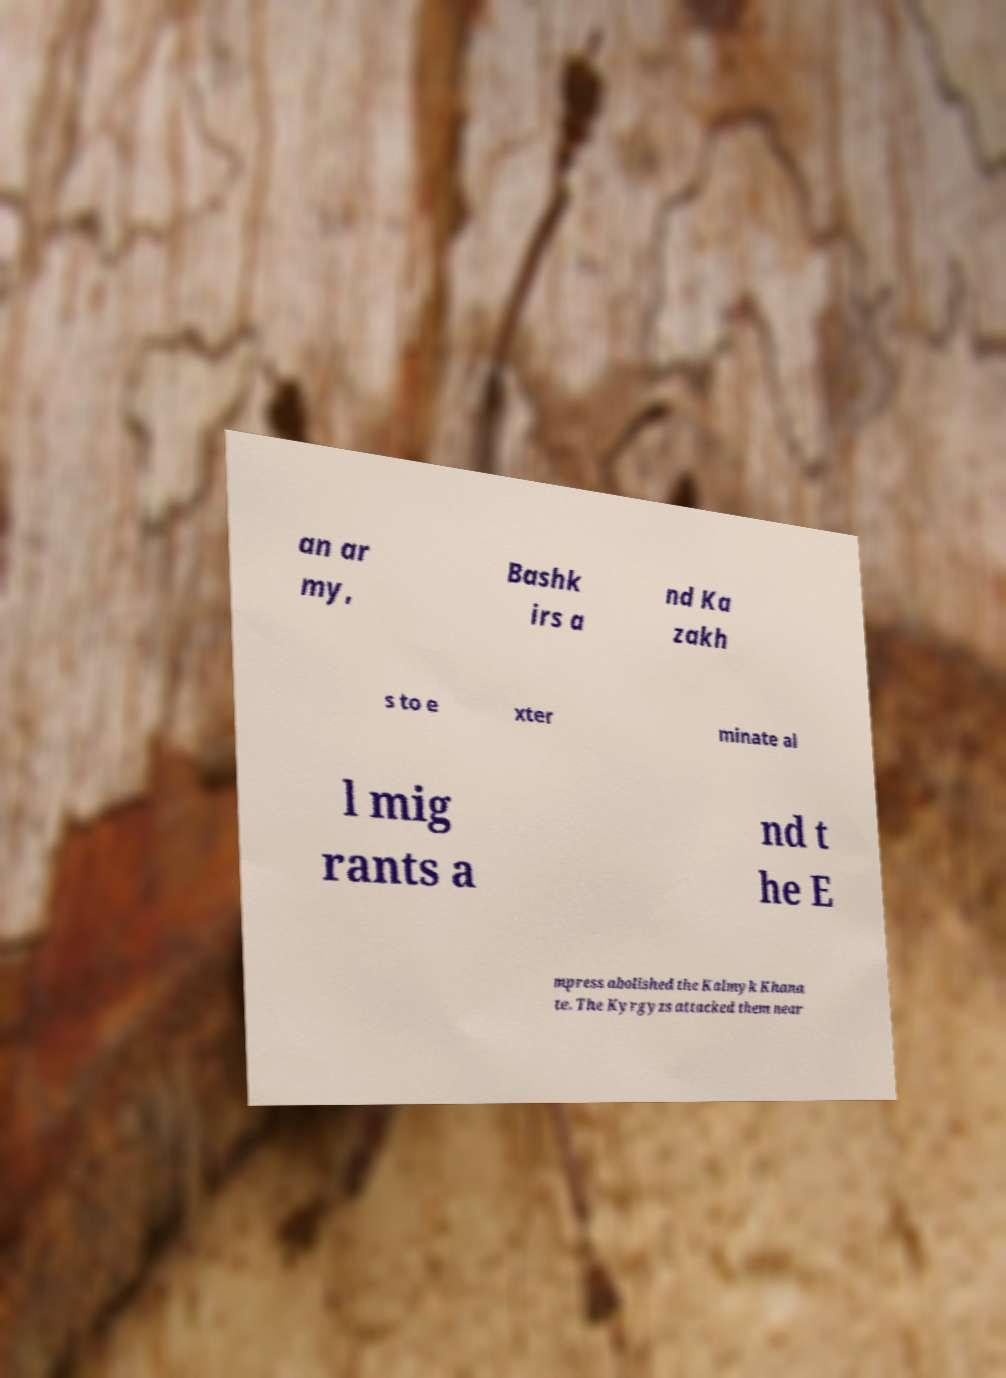There's text embedded in this image that I need extracted. Can you transcribe it verbatim? an ar my, Bashk irs a nd Ka zakh s to e xter minate al l mig rants a nd t he E mpress abolished the Kalmyk Khana te. The Kyrgyzs attacked them near 